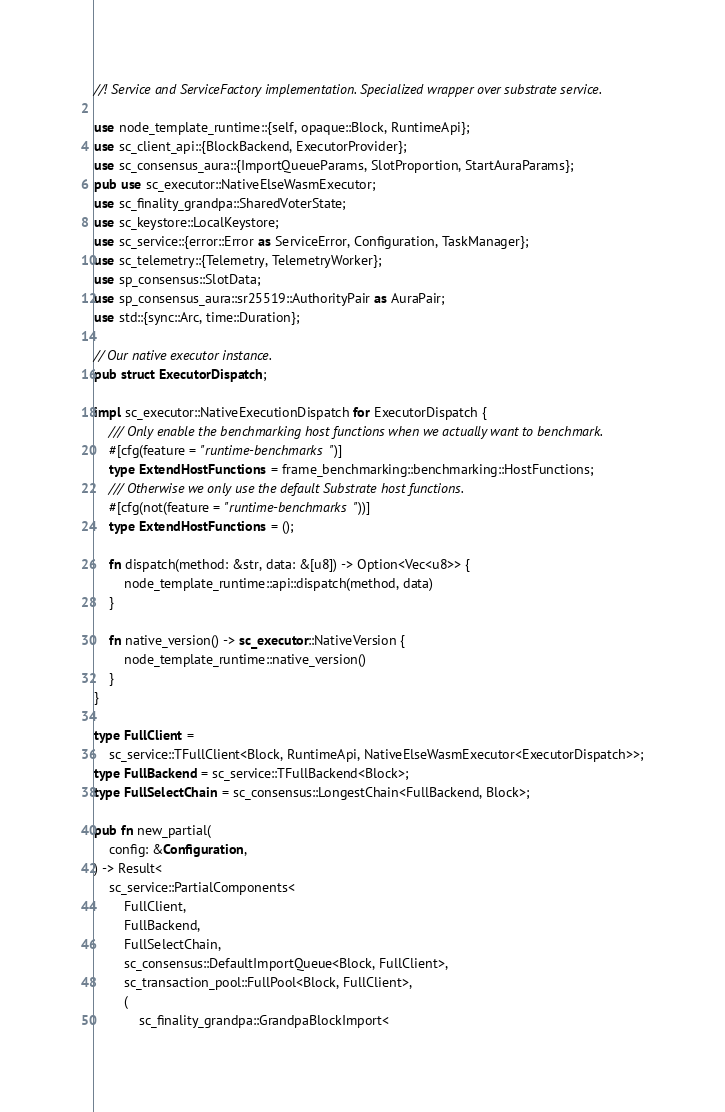Convert code to text. <code><loc_0><loc_0><loc_500><loc_500><_Rust_>//! Service and ServiceFactory implementation. Specialized wrapper over substrate service.

use node_template_runtime::{self, opaque::Block, RuntimeApi};
use sc_client_api::{BlockBackend, ExecutorProvider};
use sc_consensus_aura::{ImportQueueParams, SlotProportion, StartAuraParams};
pub use sc_executor::NativeElseWasmExecutor;
use sc_finality_grandpa::SharedVoterState;
use sc_keystore::LocalKeystore;
use sc_service::{error::Error as ServiceError, Configuration, TaskManager};
use sc_telemetry::{Telemetry, TelemetryWorker};
use sp_consensus::SlotData;
use sp_consensus_aura::sr25519::AuthorityPair as AuraPair;
use std::{sync::Arc, time::Duration};

// Our native executor instance.
pub struct ExecutorDispatch;

impl sc_executor::NativeExecutionDispatch for ExecutorDispatch {
	/// Only enable the benchmarking host functions when we actually want to benchmark.
	#[cfg(feature = "runtime-benchmarks")]
	type ExtendHostFunctions = frame_benchmarking::benchmarking::HostFunctions;
	/// Otherwise we only use the default Substrate host functions.
	#[cfg(not(feature = "runtime-benchmarks"))]
	type ExtendHostFunctions = ();

	fn dispatch(method: &str, data: &[u8]) -> Option<Vec<u8>> {
		node_template_runtime::api::dispatch(method, data)
	}

	fn native_version() -> sc_executor::NativeVersion {
		node_template_runtime::native_version()
	}
}

type FullClient =
	sc_service::TFullClient<Block, RuntimeApi, NativeElseWasmExecutor<ExecutorDispatch>>;
type FullBackend = sc_service::TFullBackend<Block>;
type FullSelectChain = sc_consensus::LongestChain<FullBackend, Block>;

pub fn new_partial(
	config: &Configuration,
) -> Result<
	sc_service::PartialComponents<
		FullClient,
		FullBackend,
		FullSelectChain,
		sc_consensus::DefaultImportQueue<Block, FullClient>,
		sc_transaction_pool::FullPool<Block, FullClient>,
		(
			sc_finality_grandpa::GrandpaBlockImport<</code> 